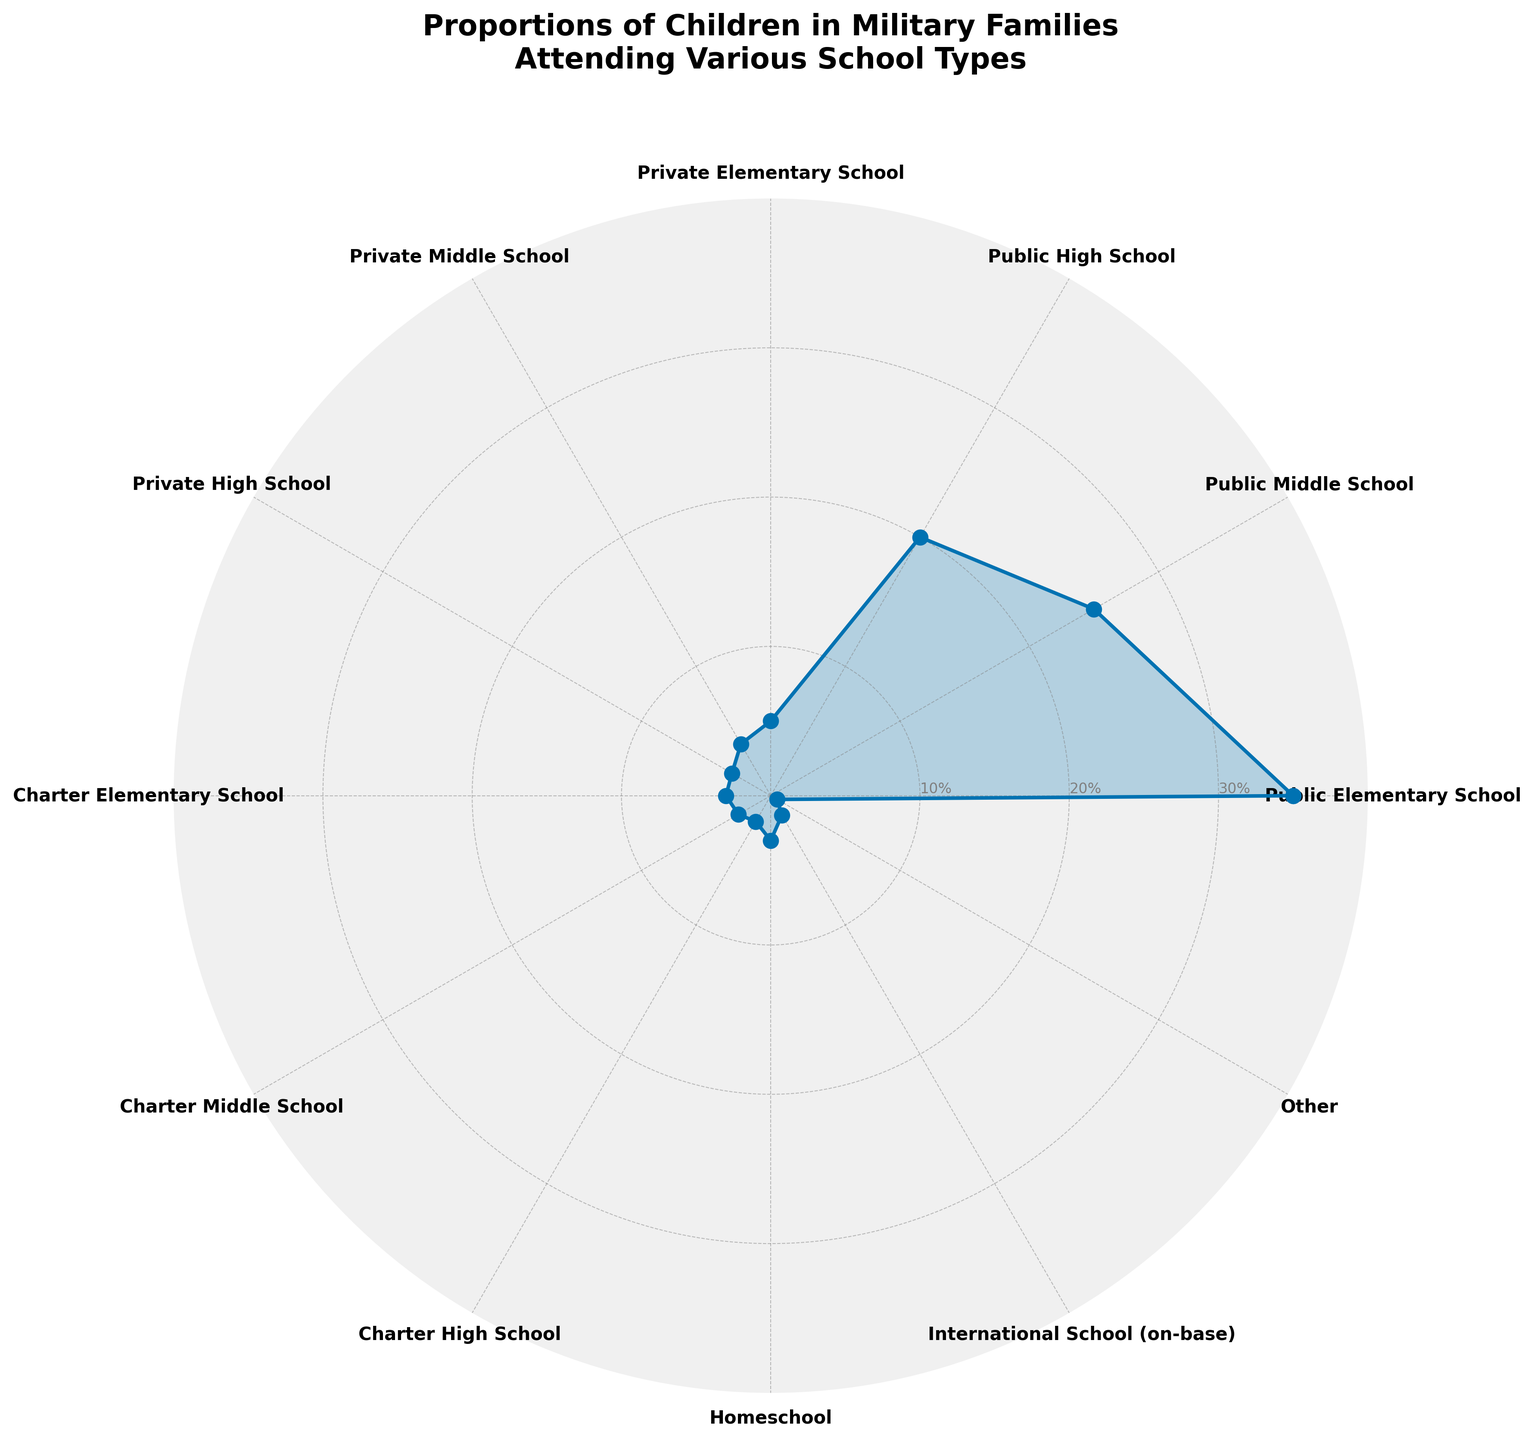Which school type shows the highest proportion of children in military families? The data on the polar chart shows different school types with their respective proportions. Looking at the maximum value on the radial axis, it's evident that 'Public Elementary School' has the highest proportion.
Answer: Public Elementary School What is the combined percentage of children attending Public High School and Charter High School? To find the combined percentage of these two school types, we sum the percentages: Public High School (20%) and Charter High School (2%). Therefore, their combined percentage is 20% + 2% = 22%.
Answer: 22% Which school type has the smallest proportion of children? By examining the radial distances on the polar chart, it becomes clear that 'Other' has the smallest proportion, indicated by the smallest value (0.5%).
Answer: Other How does the proportion of children in Private Elementary School compare to those in Private Middle School? Comparing the proportions found in the radial data points, Private Elementary School has a higher percentage (5%) compared to Private Middle School (4%).
Answer: Private Elementary School has a higher proportion What is the sum of the proportions of children attending all types of Public Schools? For this, we sum the percentages for Public Elementary School (35%), Public Middle School (25%), and Public High School (20%). The total is 35% + 25% + 20% = 80%.
Answer: 80% Which school type has a slightly higher proportion: Homeschool or Charter High School? On the polar chart, we notice that both types are close, but Homeschool (3%) has a slightly higher proportion compared to Charter High School (2%).
Answer: Homeschool What is the average proportion of all school types for children in military families? To calculate this, we sum the percentages of all school types: 35 + 25 + 20 + 5 + 4 + 3 + 3 + 2.5 + 2 + 3 + 1.5 + 0.5 = 104.5% and then divide by the number of school types (12). The average is 104.5/12 = approximately 8.71%.
Answer: 8.71% Which has a greater proportion: children attending International School (on-base) or children in Charter Middle School? Observing the chart, Charter Middle School has a proportion of 2.5%, slightly higher than International School (on-base) at 1.5%.
Answer: Charter Middle School What is the difference in proportion between children attending Public High School and Private High School? The proportions are 20% for Public High School and 3% for Private High School. The difference is 20% - 3% = 17%.
Answer: 17% How does the percentage of children attending Charter Elementary School compare to Charter Middle School? Charter Elementary School has a percentage of 3%, while Charter Middle School has 2.5%. Thus, Charter Elementary School has a higher proportion by 0.5%.
Answer: Charter Elementary School 